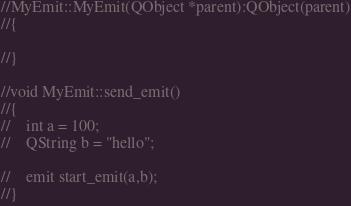Convert code to text. <code><loc_0><loc_0><loc_500><loc_500><_C++_>
//MyEmit::MyEmit(QObject *parent):QObject(parent)
//{

//}

//void MyEmit::send_emit()
//{
//    int a = 100;
//    QString b = "hello";

//    emit start_emit(a,b);
//}
</code> 